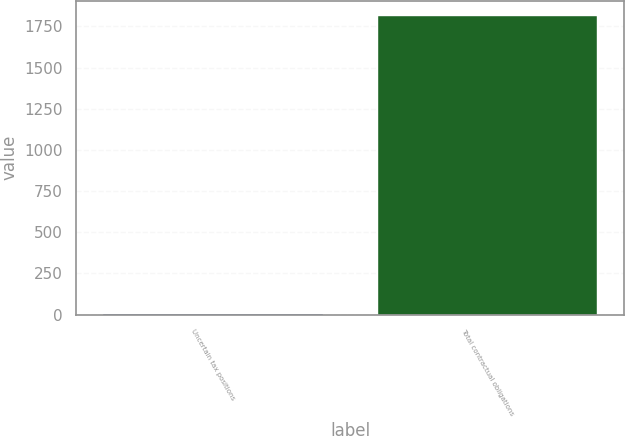Convert chart to OTSL. <chart><loc_0><loc_0><loc_500><loc_500><bar_chart><fcel>Uncertain tax positions<fcel>Total contractual obligations<nl><fcel>6.5<fcel>1815.3<nl></chart> 